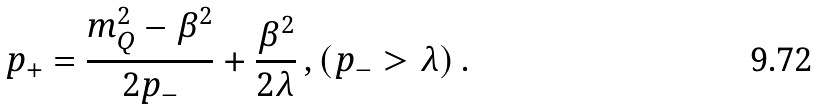<formula> <loc_0><loc_0><loc_500><loc_500>p _ { + } = \frac { m _ { Q } ^ { 2 } - \beta ^ { 2 } } { 2 p _ { - } } + \frac { \beta ^ { 2 } } { 2 \lambda } \, , ( p _ { - } > \lambda ) \, .</formula> 